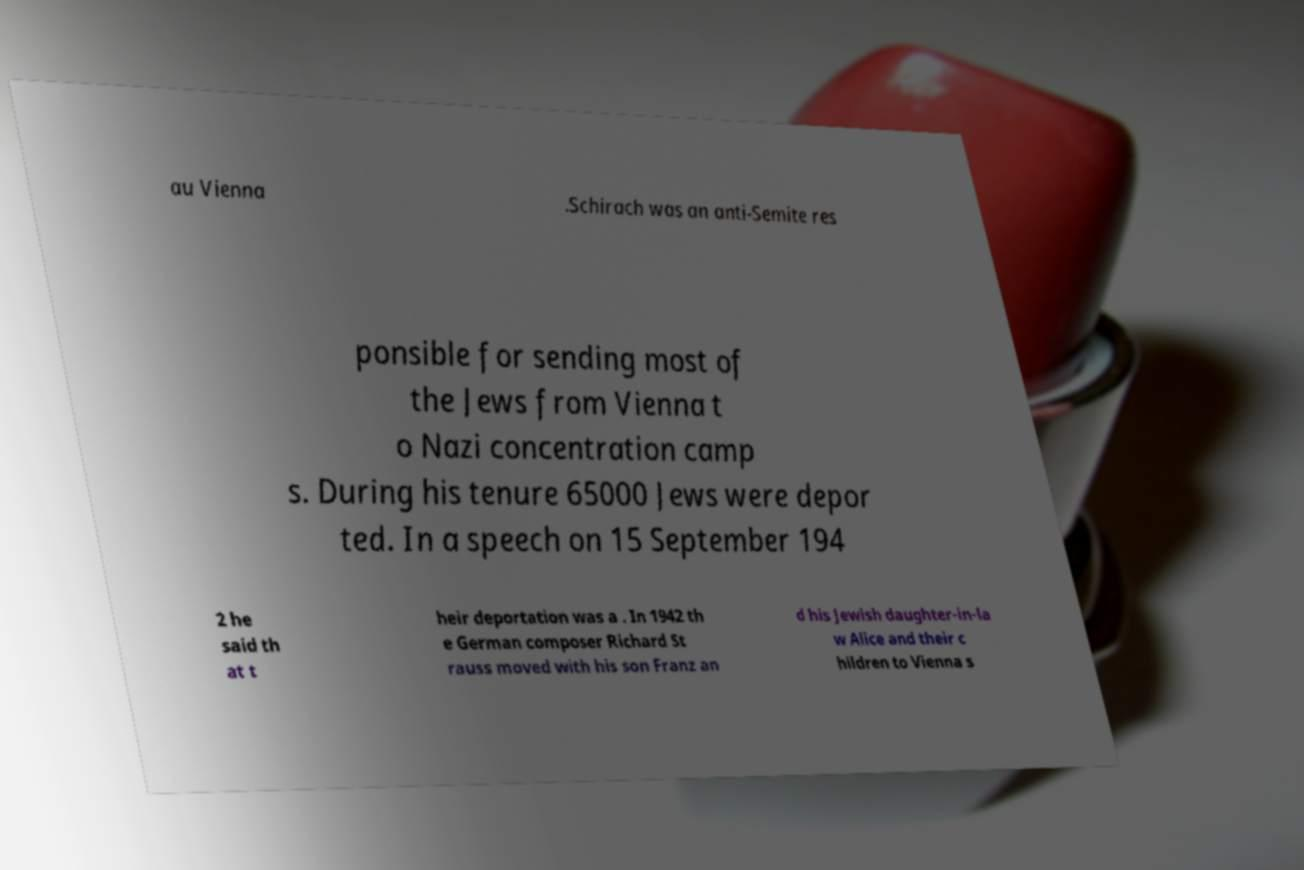Please identify and transcribe the text found in this image. au Vienna .Schirach was an anti-Semite res ponsible for sending most of the Jews from Vienna t o Nazi concentration camp s. During his tenure 65000 Jews were depor ted. In a speech on 15 September 194 2 he said th at t heir deportation was a . In 1942 th e German composer Richard St rauss moved with his son Franz an d his Jewish daughter-in-la w Alice and their c hildren to Vienna s 